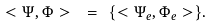<formula> <loc_0><loc_0><loc_500><loc_500>< \Psi , \Phi > \text { } = \text { } \{ < \Psi _ { e } , \Phi _ { e } > \} .</formula> 